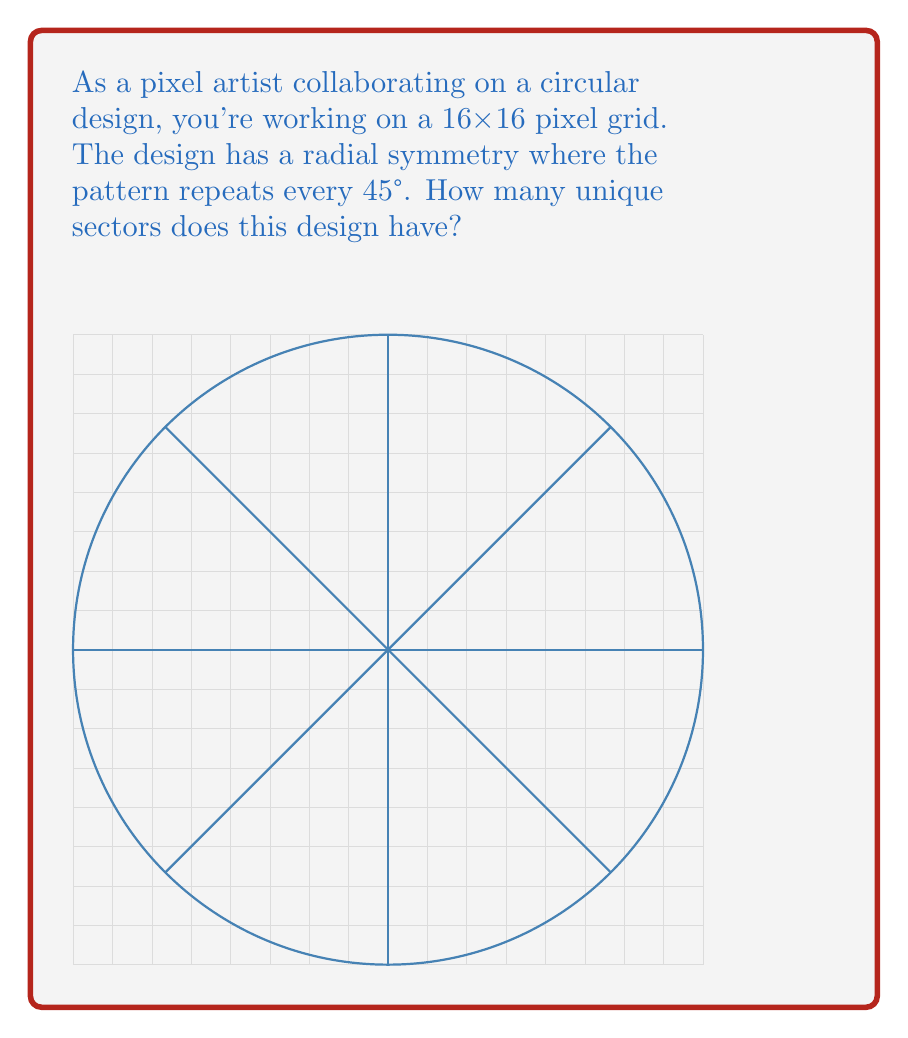Show me your answer to this math problem. To solve this problem, let's break it down step-by-step:

1) First, we need to understand what radial symmetry means. In a circular design, radial symmetry refers to the repetition of a pattern around a central point at regular intervals.

2) We're told that the pattern repeats every 45°. To calculate how many unique sectors this creates, we need to divide the full circle by this angle:

   $$\text{Number of sectors} = \frac{\text{Full circle}}{\text{Angle of repetition}} = \frac{360°}{45°}$$

3) Let's perform this calculation:

   $$\frac{360°}{45°} = 8$$

4) This means the design is divided into 8 equal sectors.

5) However, the question asks for the number of unique sectors. In radial symmetry, a unique sector is the smallest part of the design that, when repeated, creates the full pattern.

6) Since the pattern repeats every 45°, each unique sector spans 45°, which is indeed 1/8 of the full circle.

Therefore, the design has 1 unique sector that repeats 8 times to form the complete circular pattern.
Answer: 1 